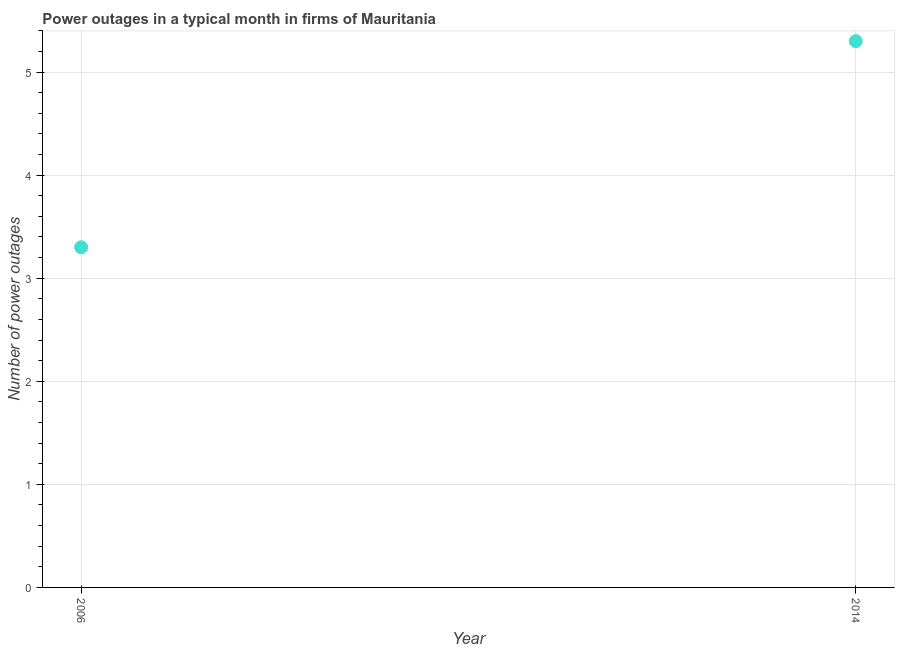What is the number of power outages in 2014?
Your answer should be very brief. 5.3. Across all years, what is the maximum number of power outages?
Offer a very short reply. 5.3. In which year was the number of power outages maximum?
Provide a succinct answer. 2014. In which year was the number of power outages minimum?
Make the answer very short. 2006. What is the median number of power outages?
Offer a terse response. 4.3. Do a majority of the years between 2006 and 2014 (inclusive) have number of power outages greater than 4 ?
Provide a succinct answer. No. What is the ratio of the number of power outages in 2006 to that in 2014?
Provide a short and direct response. 0.62. In how many years, is the number of power outages greater than the average number of power outages taken over all years?
Offer a very short reply. 1. Does the number of power outages monotonically increase over the years?
Your answer should be compact. Yes. How many dotlines are there?
Give a very brief answer. 1. What is the difference between two consecutive major ticks on the Y-axis?
Offer a terse response. 1. Are the values on the major ticks of Y-axis written in scientific E-notation?
Offer a very short reply. No. Does the graph contain any zero values?
Offer a very short reply. No. Does the graph contain grids?
Your response must be concise. Yes. What is the title of the graph?
Offer a terse response. Power outages in a typical month in firms of Mauritania. What is the label or title of the X-axis?
Offer a terse response. Year. What is the label or title of the Y-axis?
Provide a short and direct response. Number of power outages. What is the Number of power outages in 2014?
Give a very brief answer. 5.3. What is the difference between the Number of power outages in 2006 and 2014?
Your answer should be very brief. -2. What is the ratio of the Number of power outages in 2006 to that in 2014?
Keep it short and to the point. 0.62. 